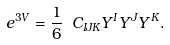<formula> <loc_0><loc_0><loc_500><loc_500>e ^ { 3 V } = \frac { 1 } { 6 } \ C _ { I J K } Y ^ { I } Y ^ { J } Y ^ { K } .</formula> 